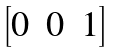<formula> <loc_0><loc_0><loc_500><loc_500>\begin{bmatrix} 0 & 0 & 1 \end{bmatrix}</formula> 